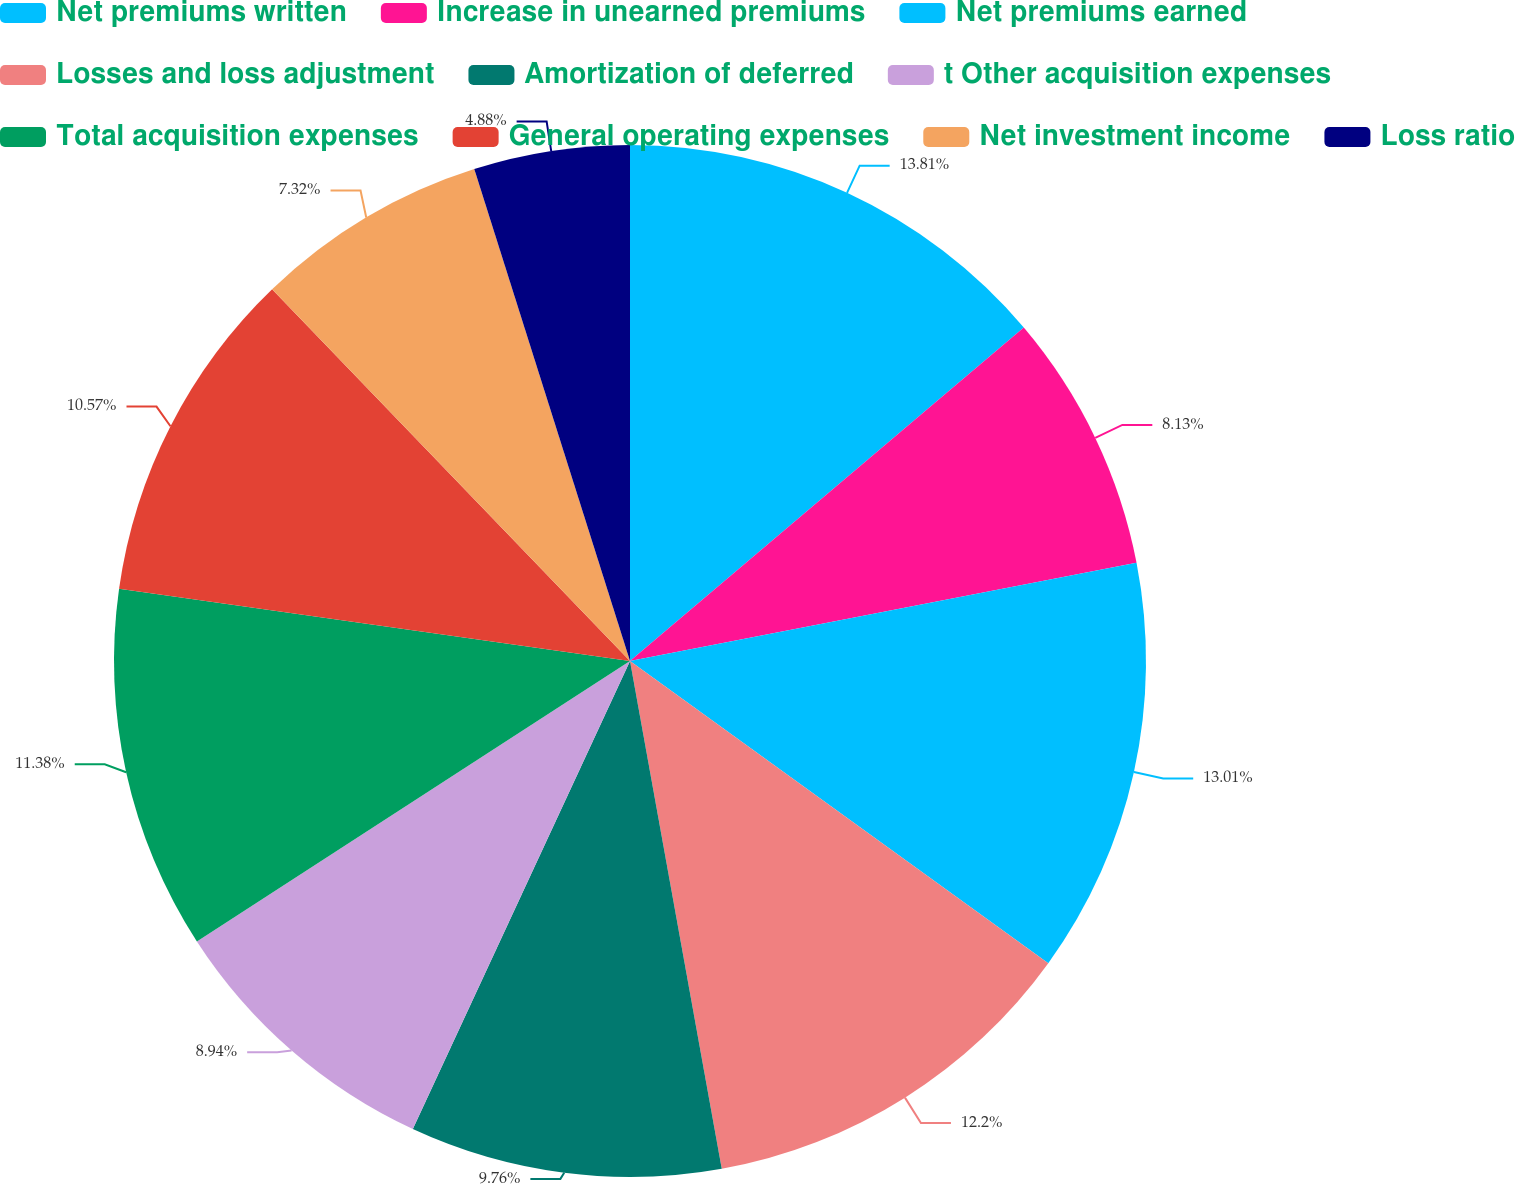Convert chart. <chart><loc_0><loc_0><loc_500><loc_500><pie_chart><fcel>Net premiums written<fcel>Increase in unearned premiums<fcel>Net premiums earned<fcel>Losses and loss adjustment<fcel>Amortization of deferred<fcel>t Other acquisition expenses<fcel>Total acquisition expenses<fcel>General operating expenses<fcel>Net investment income<fcel>Loss ratio<nl><fcel>13.82%<fcel>8.13%<fcel>13.01%<fcel>12.2%<fcel>9.76%<fcel>8.94%<fcel>11.38%<fcel>10.57%<fcel>7.32%<fcel>4.88%<nl></chart> 